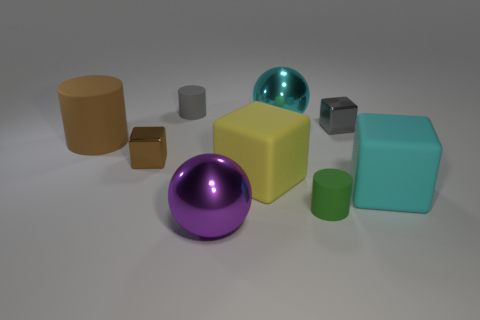Subtract all small brown metallic blocks. How many blocks are left? 3 Subtract all brown blocks. How many blocks are left? 3 Add 1 tiny gray cylinders. How many objects exist? 10 Subtract all large cyan blocks. Subtract all yellow matte blocks. How many objects are left? 7 Add 5 big balls. How many big balls are left? 7 Add 8 gray things. How many gray things exist? 10 Subtract 1 brown cubes. How many objects are left? 8 Subtract all cylinders. How many objects are left? 6 Subtract 1 balls. How many balls are left? 1 Subtract all blue cubes. Subtract all gray cylinders. How many cubes are left? 4 